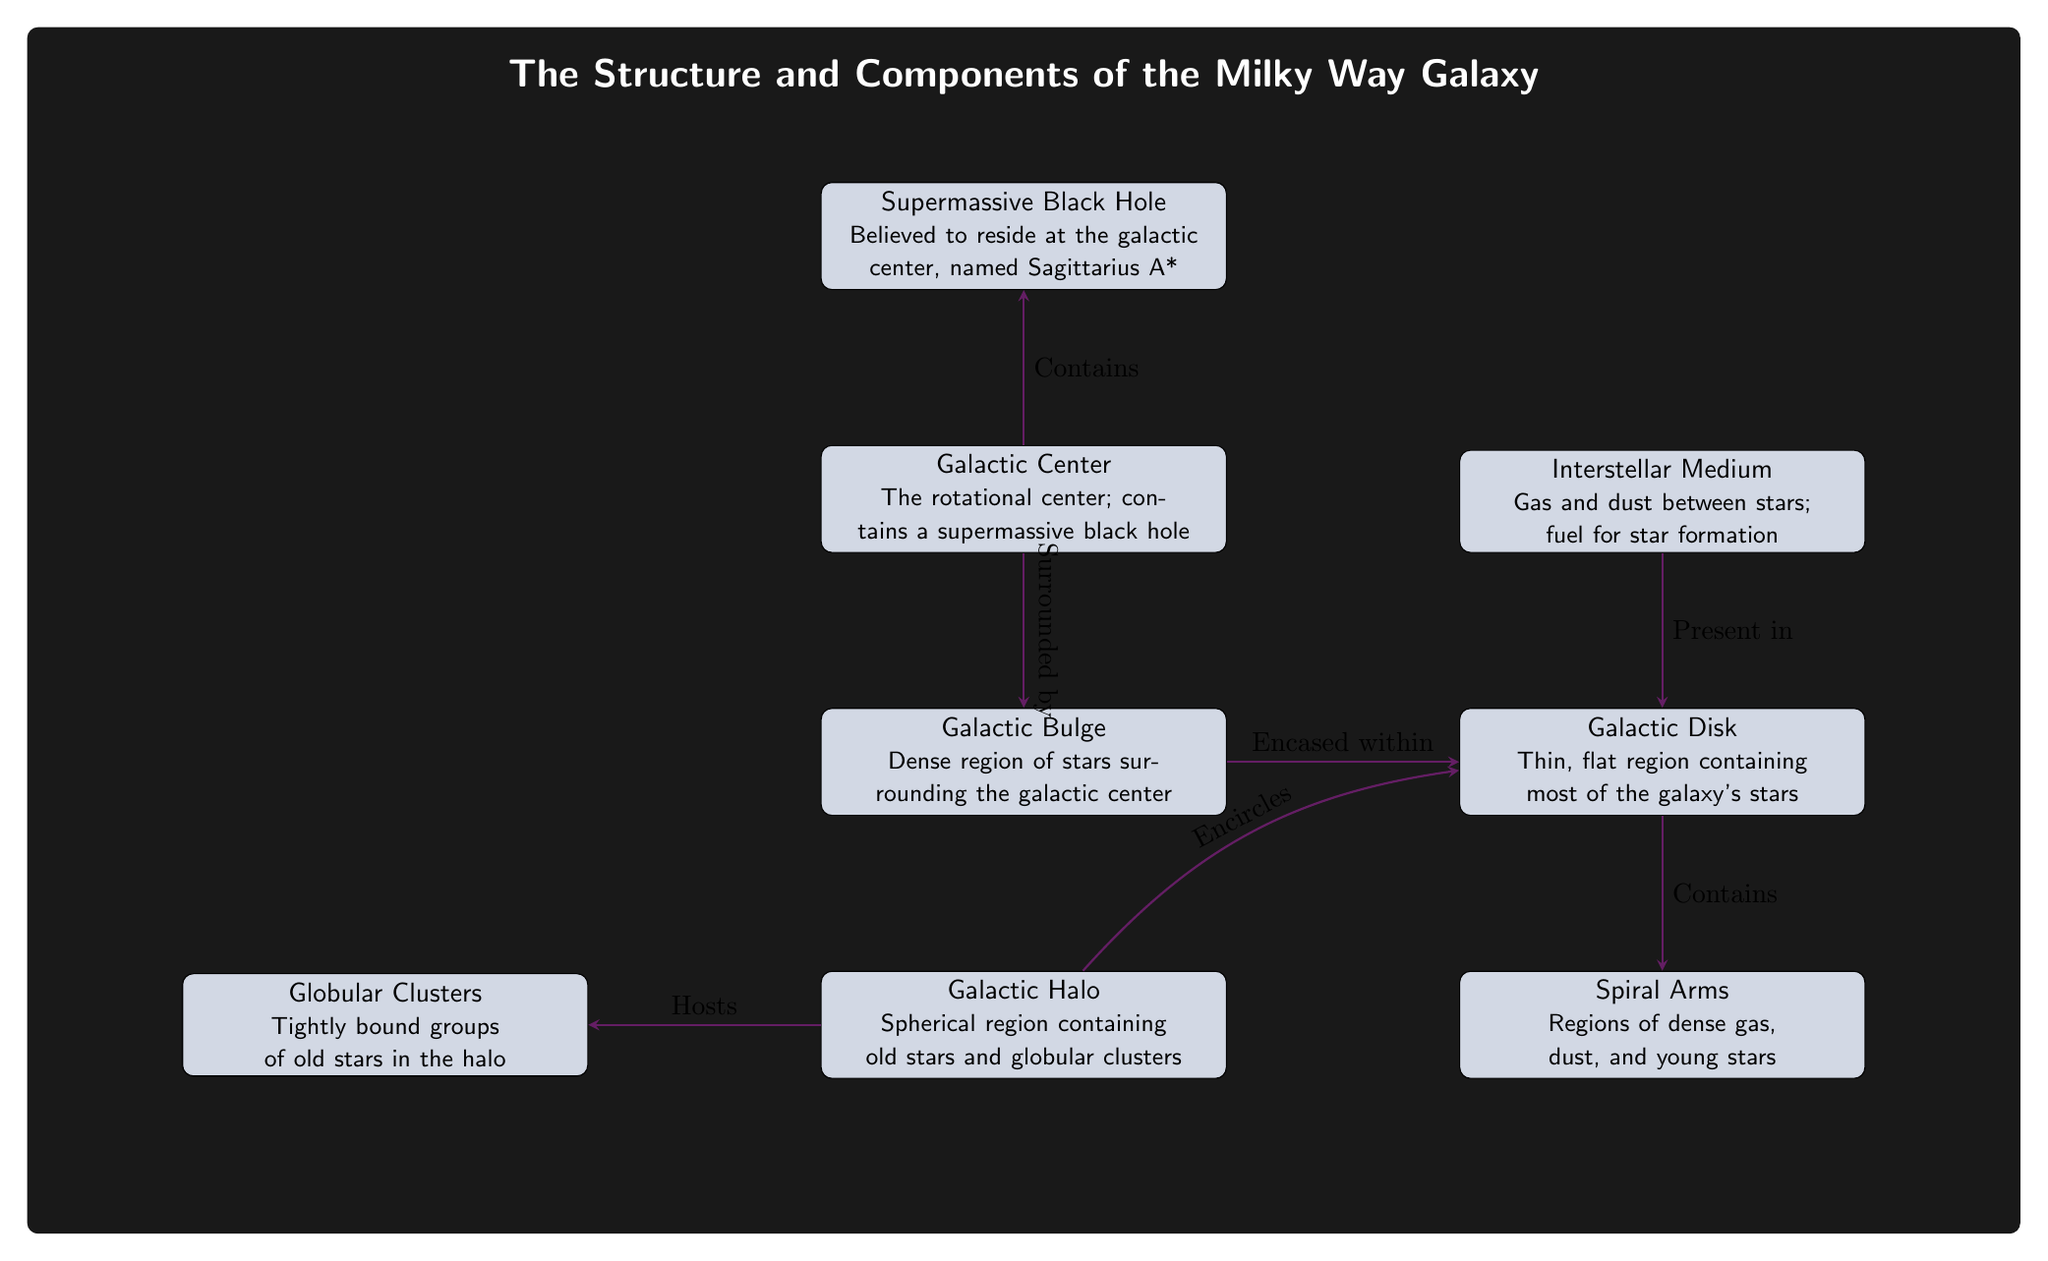What is located at the galactic center? The diagram shows that the Galactic Center contains a supermassive black hole. This is directly stated in the description of the Galactic Center node.
Answer: supermassive black hole What surrounds the galactic center? According to the diagram, the Galactic Bulge surrounds the Galactic Center. The connection arrow labeled "Surrounded by" indicates this relationship.
Answer: Galactic Bulge Which component contains most of the galaxy's stars? The diagram specifies that the Galactic Disk is the component that contains most of the galaxy's stars, as stated in its description.
Answer: Galactic Disk What does the Galactic Halo host? The diagram indicates that the Galactic Halo hosts Globular Clusters. This is derived from the connection labeled "Hosts" leading from Halo to Clusters.
Answer: Globular Clusters Which component is situated above the Galactic Disk? The Interstellar Medium is illustrated above the Galactic Disk in the diagram layout and is directly related according to the connection arrows.
Answer: Interstellar Medium What connects the Galactic Bulge and the Galactic Disk? The connection labeled "Encased within" indicates that the Galactic Bulge is encased within the Galactic Disk, showing a direct relationship between these two components.
Answer: Galactic Disk How many major components are depicted in the diagram? By counting the distinct nodes that represent major components in the diagram, we can see there are seven: Galactic Center, Galactic Bulge, Galactic Disk, Spiral Arms, Galactic Halo, Supermassive Black Hole, and Interstellar Medium.
Answer: 7 Which feature is said to be believed to be at the galactic center? The Supermassive Black Hole is stated as being believed to reside at the galactic center in the description provided within the node.
Answer: Sagittarius A* What component is associated with young stars? The Spiral Arms are associated with young stars as indicated in the description of the node. The connection arrow points from the Galactic Disk to the Spiral Arms, highlighting this relationship.
Answer: Spiral Arms 